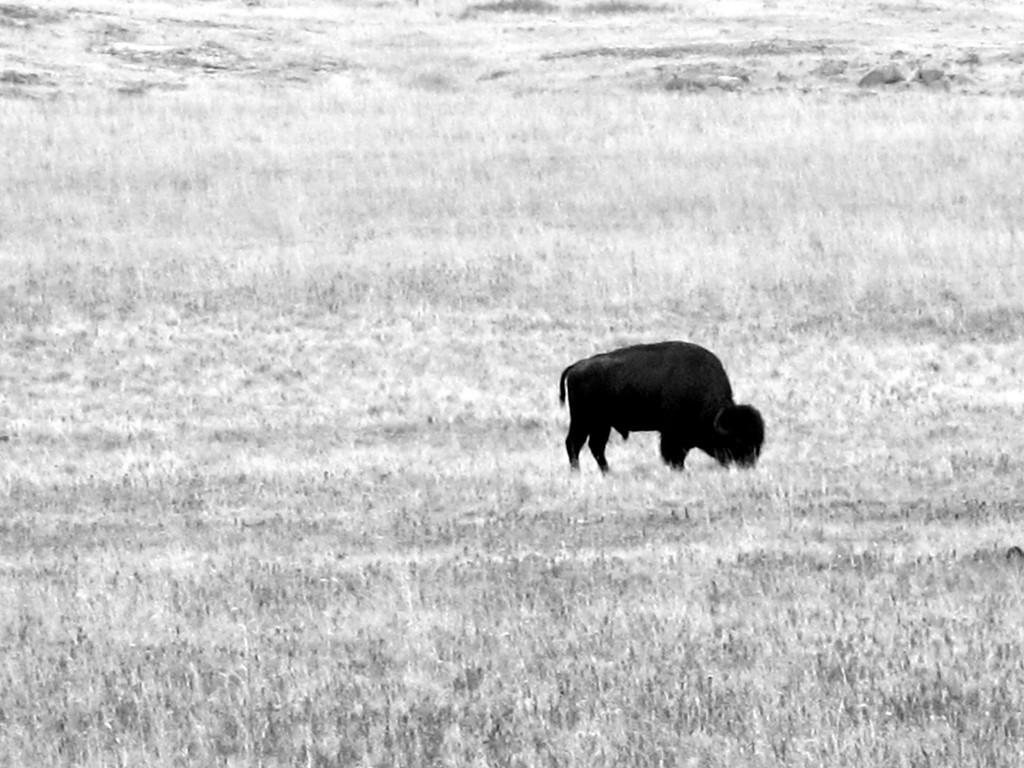What type of animal can be seen in the image? There is a black color animal in the image. Where is the animal located in the image? The animal is on the ground. What type of vegetation is visible in the image? There is grass visible in the image. How is the image presented in terms of color? The image is in black and white mode. How many trucks are visible in the image? There are no trucks present in the image. Can you describe the zipper on the animal's fur in the image? There is no zipper on the animal's fur in the image, as it is a black and white photograph and zippers are not visible in this mode. 